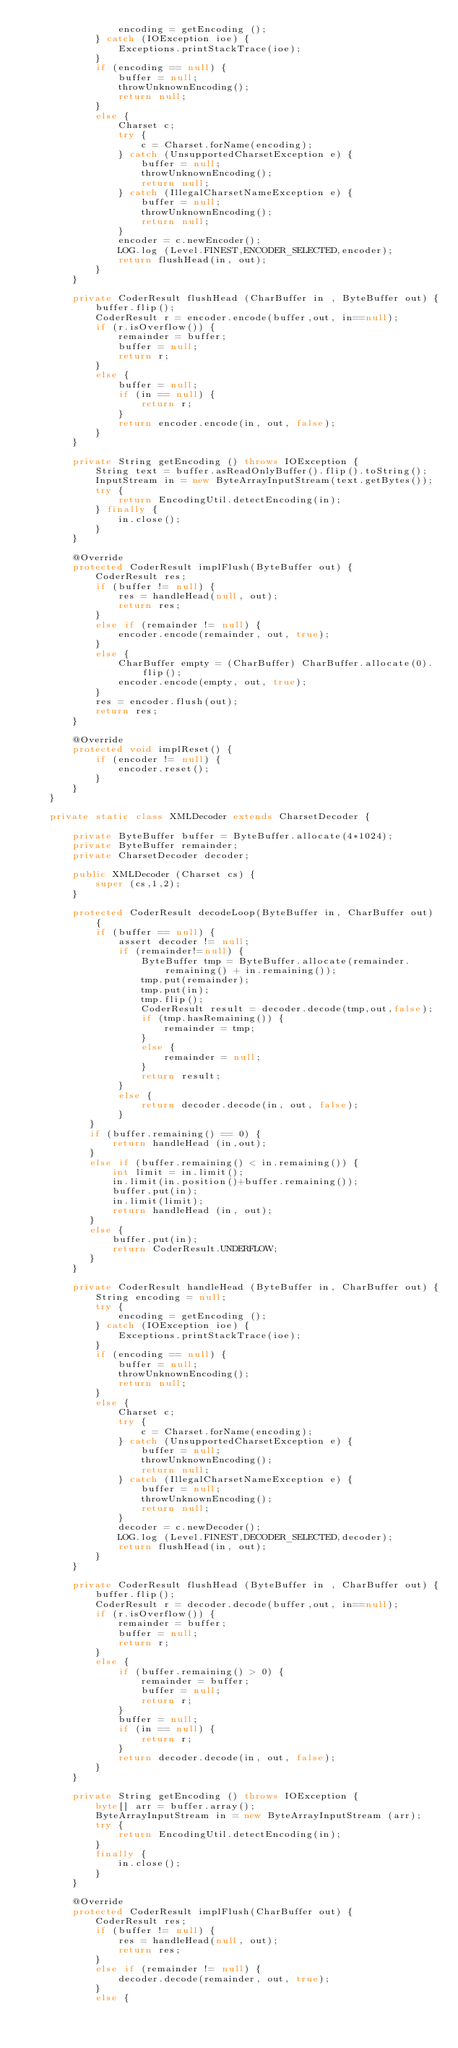Convert code to text. <code><loc_0><loc_0><loc_500><loc_500><_Java_>                encoding = getEncoding ();
            } catch (IOException ioe) {
                Exceptions.printStackTrace(ioe);
            }
            if (encoding == null) {          
                buffer = null;
                throwUnknownEncoding();
                return null;
            }
            else {
                Charset c;
                try {
                    c = Charset.forName(encoding);
                } catch (UnsupportedCharsetException e) {
                    buffer = null;
                    throwUnknownEncoding();
                    return null;
                } catch (IllegalCharsetNameException e) {
                    buffer = null;
                    throwUnknownEncoding();
                    return null;
                }
                encoder = c.newEncoder();
                LOG.log (Level.FINEST,ENCODER_SELECTED,encoder);
                return flushHead(in, out);
            }
        }

        private CoderResult flushHead (CharBuffer in , ByteBuffer out) {
            buffer.flip();
            CoderResult r = encoder.encode(buffer,out, in==null);
            if (r.isOverflow()) {
                remainder = buffer;
                buffer = null;
                return r;
            }
            else {
                buffer = null;
                if (in == null) {
                    return r;
                }
                return encoder.encode(in, out, false);
            }
        }

        private String getEncoding () throws IOException {
            String text = buffer.asReadOnlyBuffer().flip().toString();
            InputStream in = new ByteArrayInputStream(text.getBytes());
            try {
                return EncodingUtil.detectEncoding(in);
            } finally {
                in.close();
            }
        }

        @Override
        protected CoderResult implFlush(ByteBuffer out) {
            CoderResult res;
            if (buffer != null) {
                res = handleHead(null, out);
                return res;
            }
            else if (remainder != null) {
                encoder.encode(remainder, out, true);
            }
            else {
                CharBuffer empty = (CharBuffer) CharBuffer.allocate(0).flip();
                encoder.encode(empty, out, true);
            }
            res = encoder.flush(out);
            return res;
        }

        @Override
        protected void implReset() {
            if (encoder != null) {
                encoder.reset();
            }
        }           
    }

    private static class XMLDecoder extends CharsetDecoder {

        private ByteBuffer buffer = ByteBuffer.allocate(4*1024);
        private ByteBuffer remainder;
        private CharsetDecoder decoder;

        public XMLDecoder (Charset cs) {
            super (cs,1,2);
        }
        
        protected CoderResult decodeLoop(ByteBuffer in, CharBuffer out) {
            if (buffer == null) {                
                assert decoder != null;
                if (remainder!=null) {
                    ByteBuffer tmp = ByteBuffer.allocate(remainder.remaining() + in.remaining());
                    tmp.put(remainder);
                    tmp.put(in);
                    tmp.flip();
                    CoderResult result = decoder.decode(tmp,out,false);
                    if (tmp.hasRemaining()) {
                        remainder = tmp;
                    }
                    else {
                        remainder = null;
                    }
                    return result;
                }
                else {
                    return decoder.decode(in, out, false);
                }
           }
           if (buffer.remaining() == 0) {
               return handleHead (in,out);
           }
           else if (buffer.remaining() < in.remaining()) {
               int limit = in.limit();
               in.limit(in.position()+buffer.remaining());
               buffer.put(in);
               in.limit(limit);
               return handleHead (in, out);
           }
           else {
               buffer.put(in);
               return CoderResult.UNDERFLOW;
           }
        }

        private CoderResult handleHead (ByteBuffer in, CharBuffer out) {
            String encoding = null;
            try {
                encoding = getEncoding ();
            } catch (IOException ioe) {
                Exceptions.printStackTrace(ioe);
            }
            if (encoding == null) {          
                buffer = null;
                throwUnknownEncoding();
                return null;
            }
            else {
                Charset c;
                try {
                    c = Charset.forName(encoding);
                } catch (UnsupportedCharsetException e) {
                    buffer = null;
                    throwUnknownEncoding();
                    return null;
                } catch (IllegalCharsetNameException e) {
                    buffer = null;
                    throwUnknownEncoding();
                    return null;
                }
                decoder = c.newDecoder();
                LOG.log (Level.FINEST,DECODER_SELECTED,decoder);
                return flushHead(in, out);
            }
        }

        private CoderResult flushHead (ByteBuffer in , CharBuffer out) {
            buffer.flip();
            CoderResult r = decoder.decode(buffer,out, in==null);
            if (r.isOverflow()) {                
                remainder = buffer;
                buffer = null;
                return r;
            }
            else {
                if (buffer.remaining() > 0) {
                    remainder = buffer;
                    buffer = null;
                    return r;
                }
                buffer = null;
                if (in == null) {
                    return r;
                }
                return decoder.decode(in, out, false);
            }
        }

        private String getEncoding () throws IOException {
            byte[] arr = buffer.array();
            ByteArrayInputStream in = new ByteArrayInputStream (arr);
            try {
                return EncodingUtil.detectEncoding(in);
            }            
            finally {
                in.close();                
            }
        }

        @Override
        protected CoderResult implFlush(CharBuffer out) {
            CoderResult res;
            if (buffer != null) {
                res = handleHead(null, out);
                return res;
            }
            else if (remainder != null) {
                decoder.decode(remainder, out, true);
            }
            else {</code> 